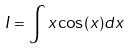Convert formula to latex. <formula><loc_0><loc_0><loc_500><loc_500>I = \int x \cos ( x ) d x</formula> 